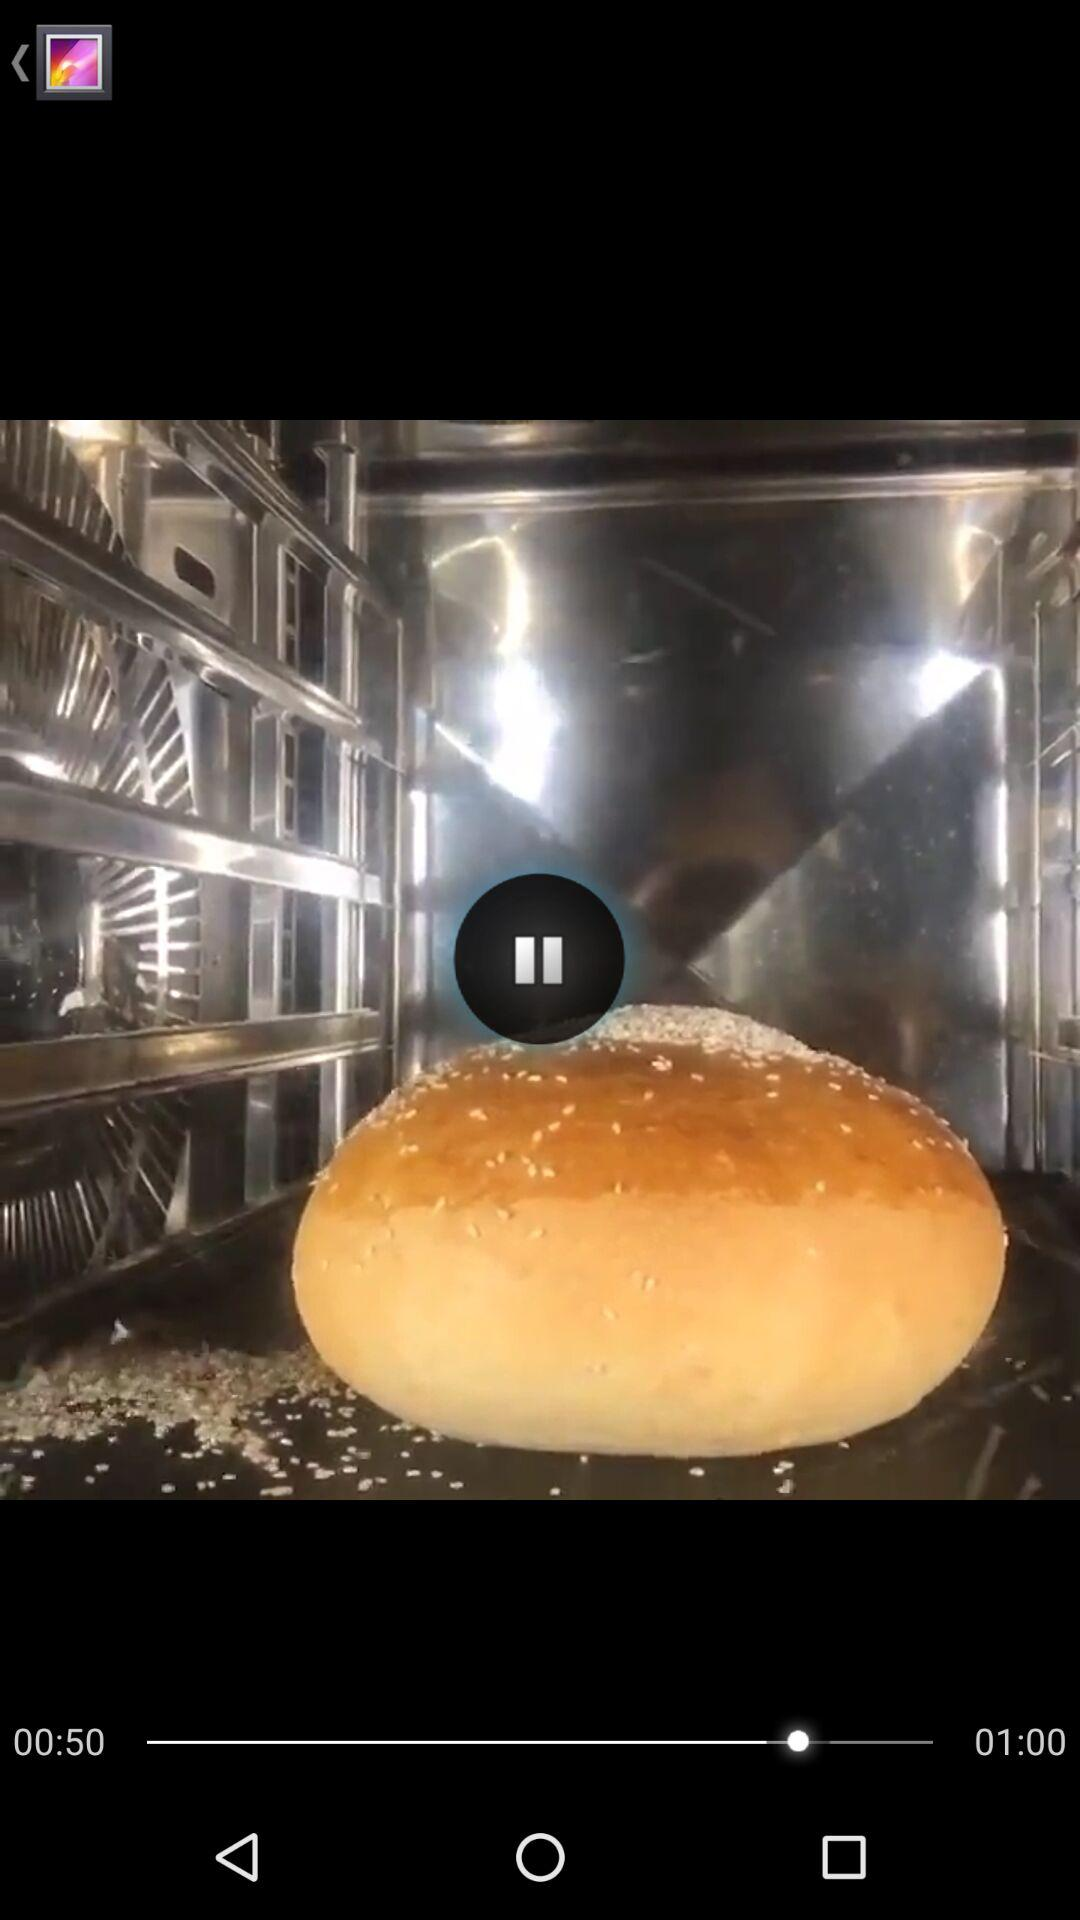What is the difference between the two times shown on the screen?
Answer the question using a single word or phrase. 10 